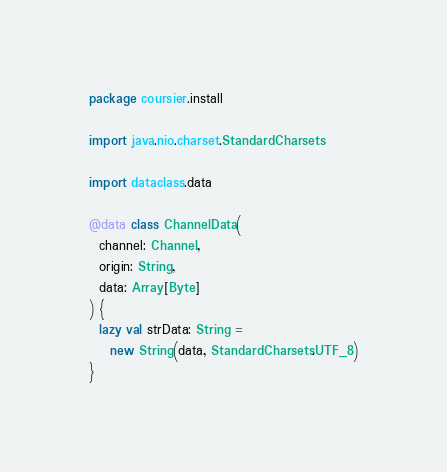Convert code to text. <code><loc_0><loc_0><loc_500><loc_500><_Scala_>package coursier.install

import java.nio.charset.StandardCharsets

import dataclass.data

@data class ChannelData(
  channel: Channel,
  origin: String,
  data: Array[Byte]
) {
  lazy val strData: String =
    new String(data, StandardCharsets.UTF_8)
}
</code> 